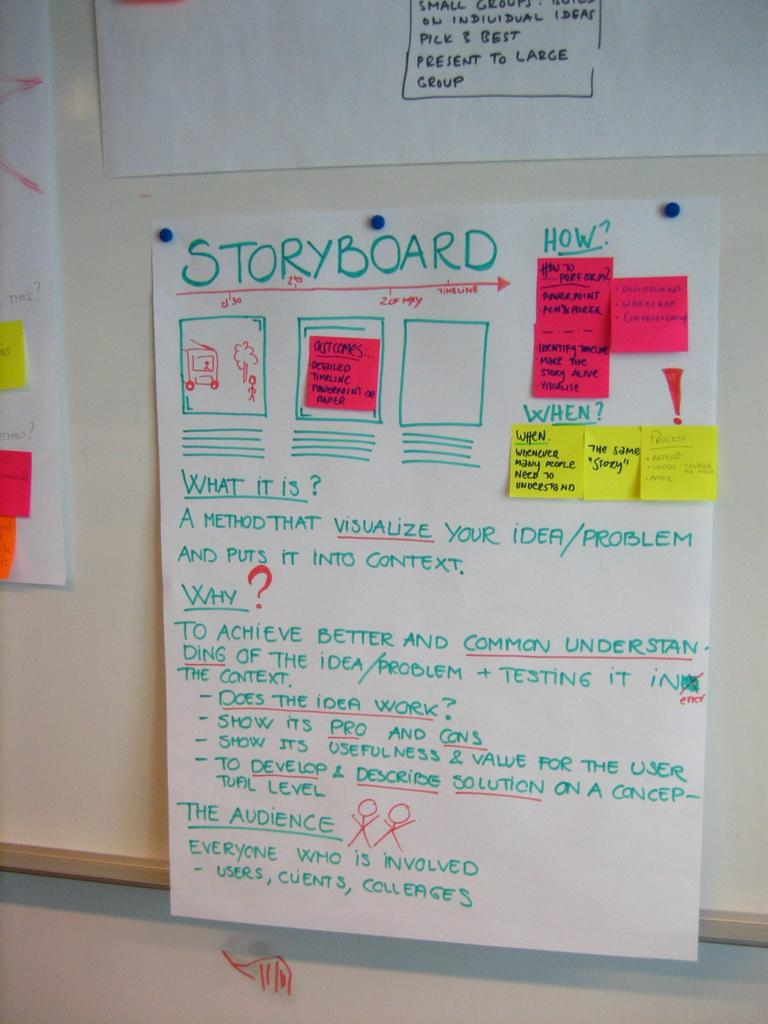Provide a one-sentence caption for the provided image. A bulletin board with Storyboard flow chart example pinned to it. 